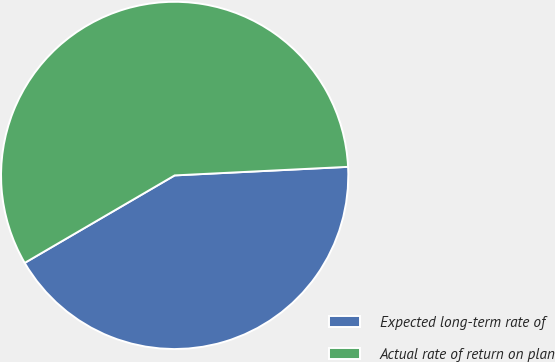<chart> <loc_0><loc_0><loc_500><loc_500><pie_chart><fcel>Expected long-term rate of<fcel>Actual rate of return on plan<nl><fcel>42.38%<fcel>57.62%<nl></chart> 